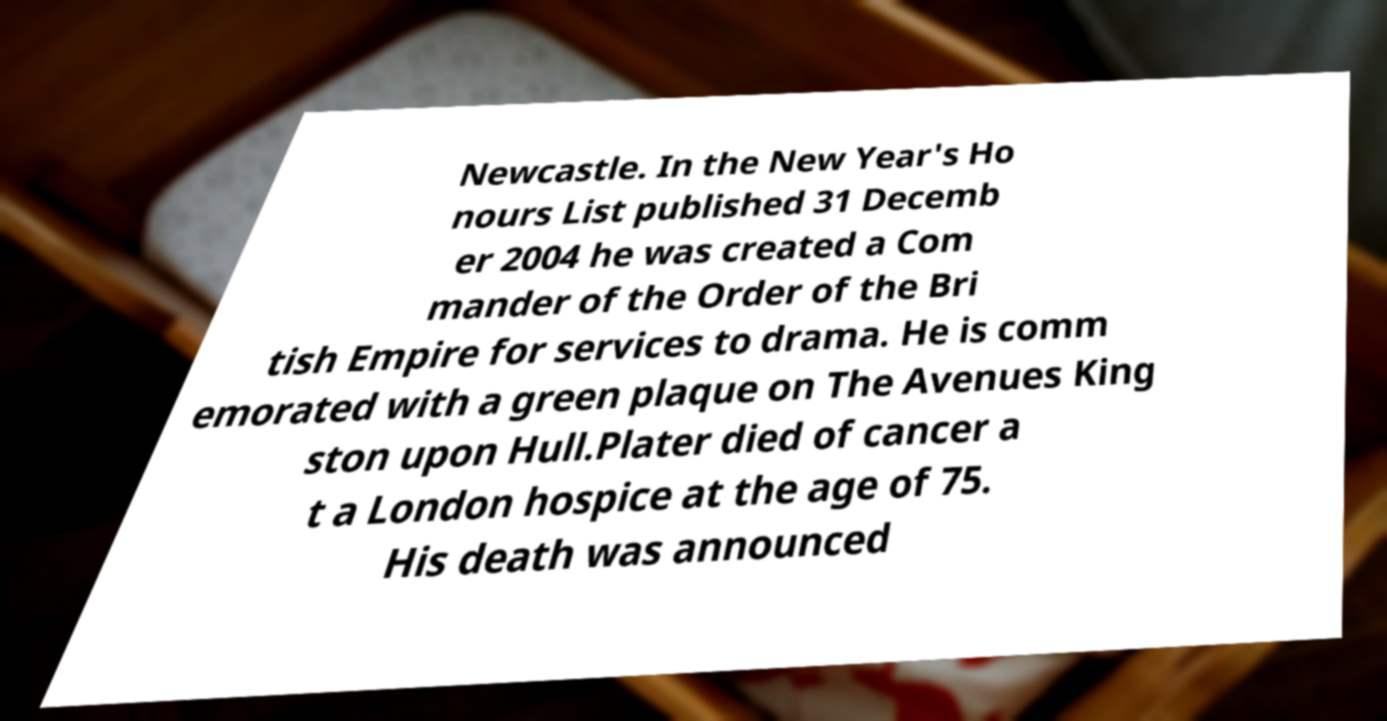Can you accurately transcribe the text from the provided image for me? Newcastle. In the New Year's Ho nours List published 31 Decemb er 2004 he was created a Com mander of the Order of the Bri tish Empire for services to drama. He is comm emorated with a green plaque on The Avenues King ston upon Hull.Plater died of cancer a t a London hospice at the age of 75. His death was announced 